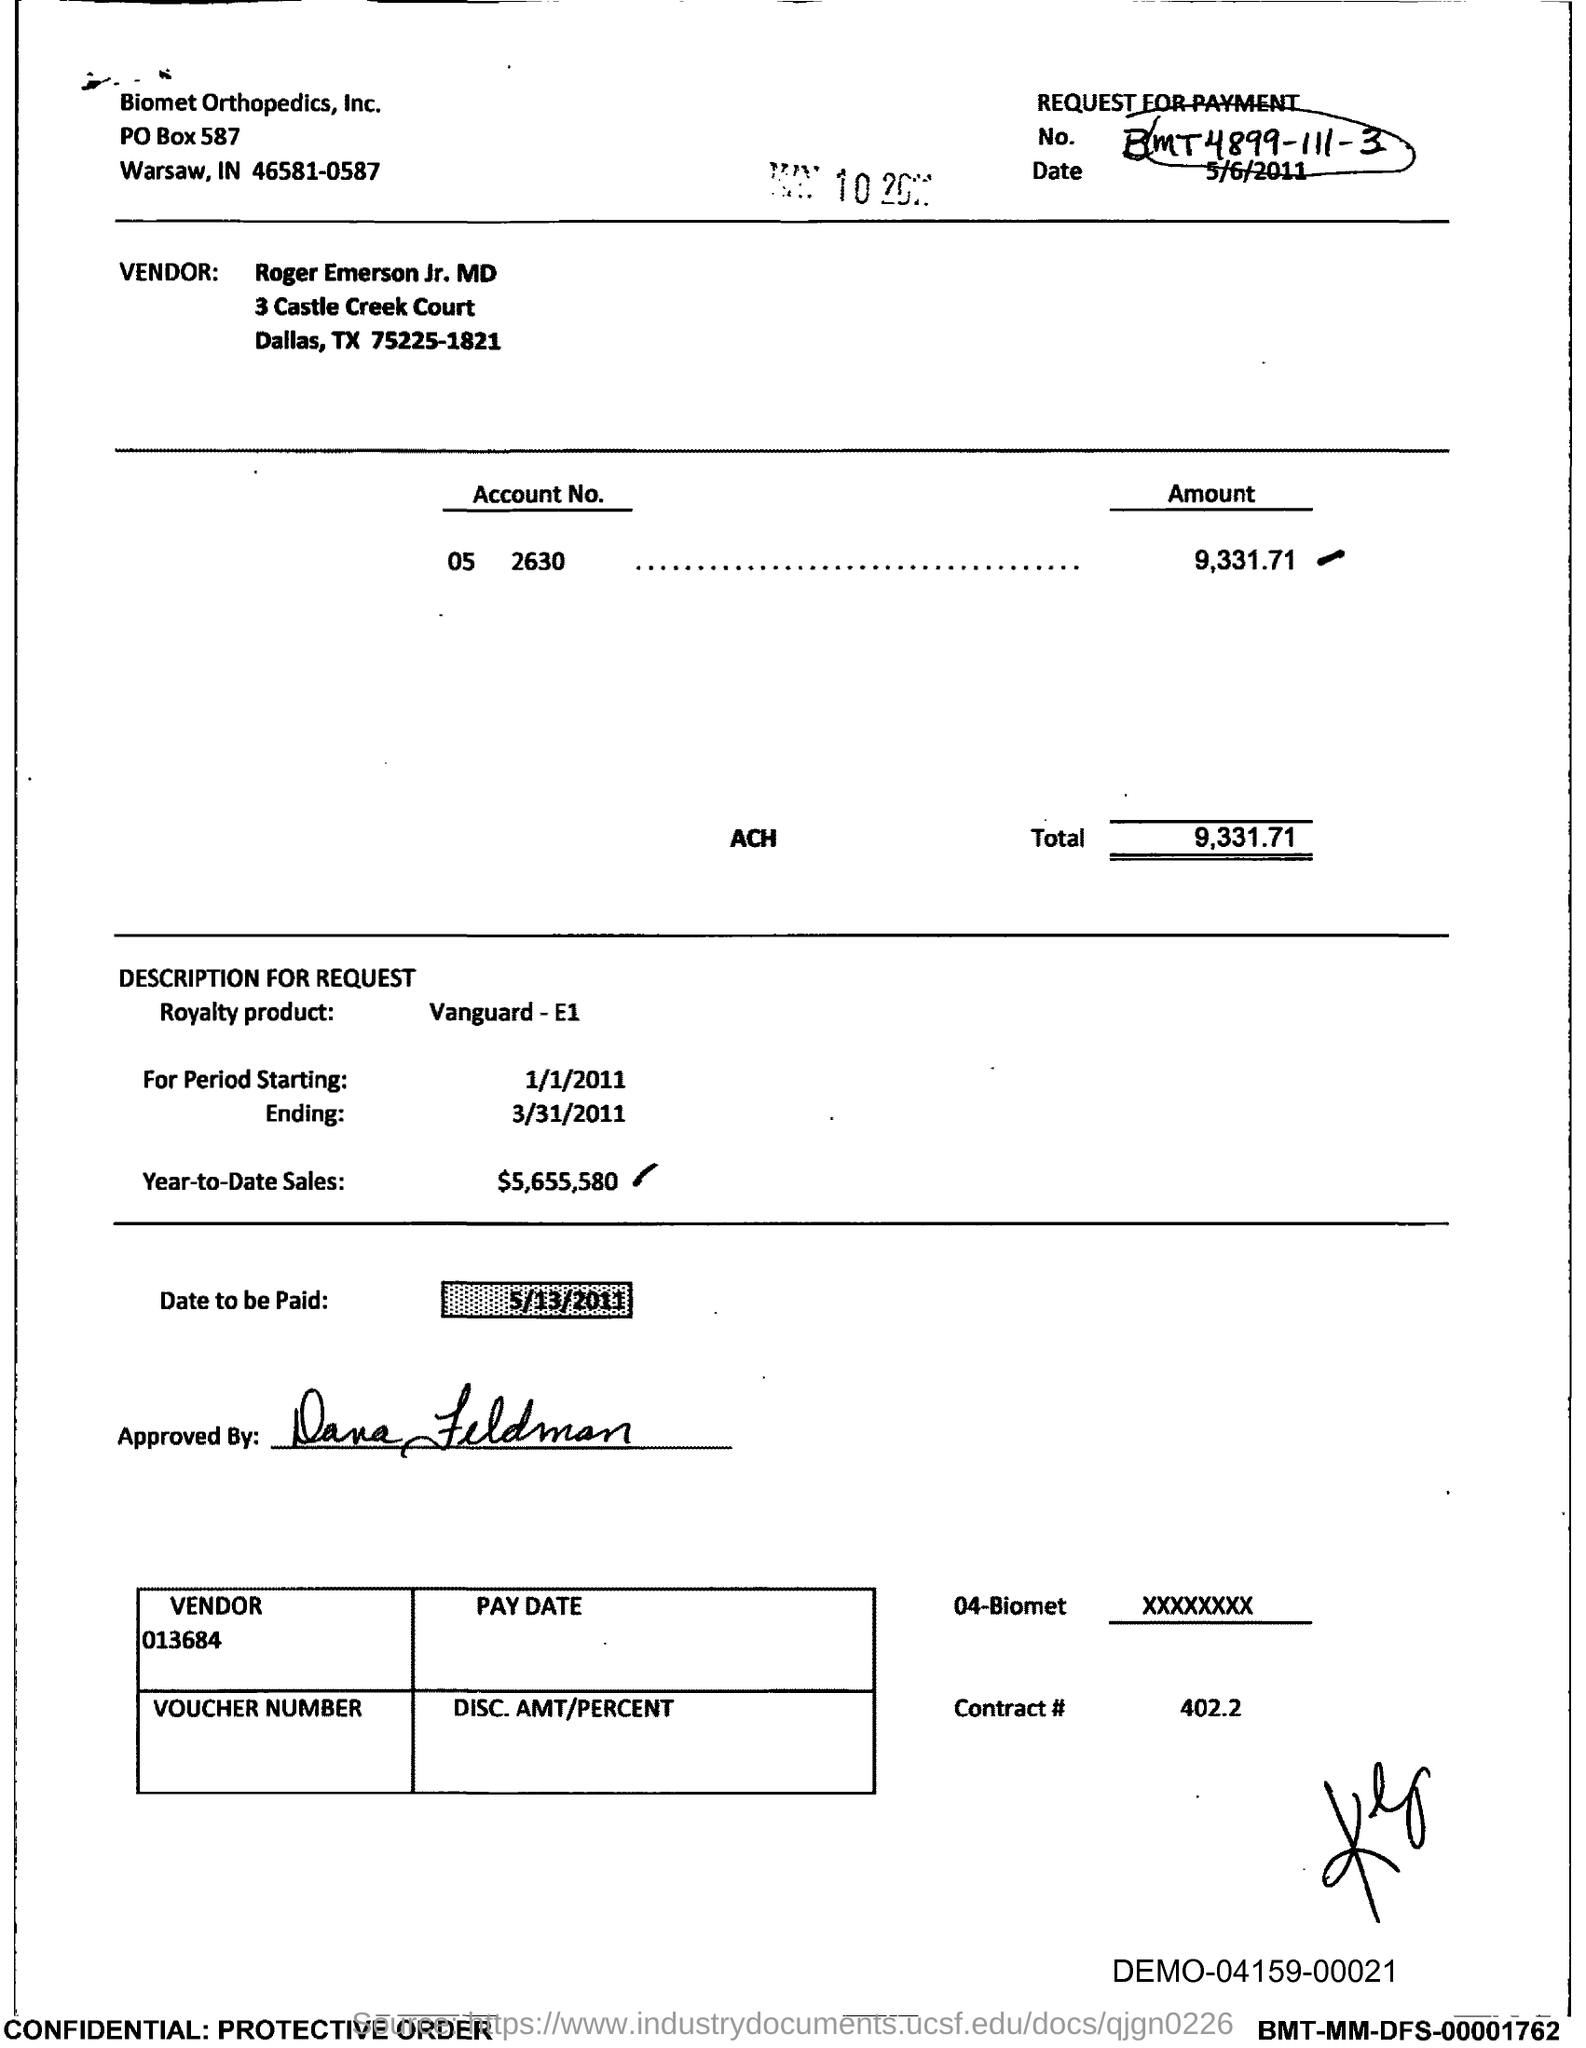What is the request for payment no. given in the document?
Make the answer very short. MT4899-111-3. What is the issued date of this document?
Make the answer very short. 5/6/2011. What is the Account No. given in the document?
Offer a terse response. 05 2630. What is the total amount to be paid as per the document?
Give a very brief answer. 9,331.71. What is the royalty product mentioned in the document?
Make the answer very short. VANGUARD- E1. What is the start date of the royalty period?
Offer a very short reply. 1/1/2011. What is the Year-to-Date Sales of the royalty product?
Make the answer very short. $5,655,580. What is the contract # given in the document?
Make the answer very short. 402.2. What is the vendor number given in the document?
Offer a very short reply. 013684. 